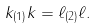Convert formula to latex. <formula><loc_0><loc_0><loc_500><loc_500>k _ { ( 1 ) } k = \ell _ { ( 2 ) } \ell .</formula> 